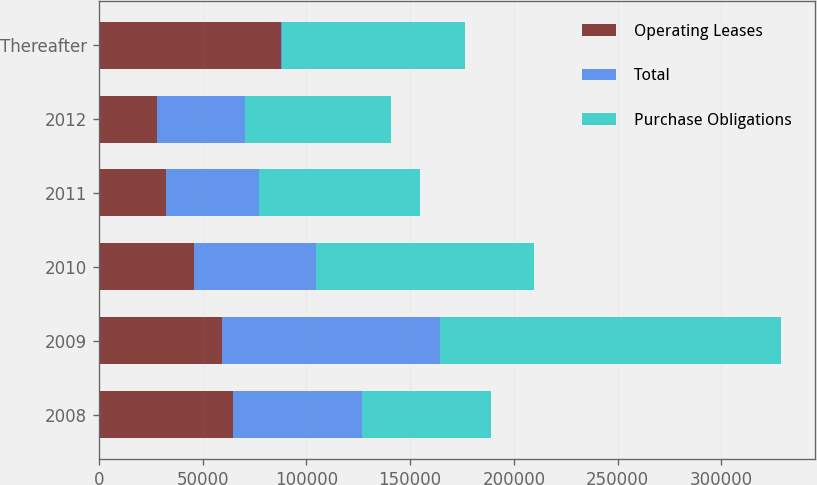Convert chart to OTSL. <chart><loc_0><loc_0><loc_500><loc_500><stacked_bar_chart><ecel><fcel>2008<fcel>2009<fcel>2010<fcel>2011<fcel>2012<fcel>Thereafter<nl><fcel>Operating Leases<fcel>64870<fcel>59221<fcel>45960<fcel>32342<fcel>27940<fcel>87688<nl><fcel>Total<fcel>62045.5<fcel>105099<fcel>58786<fcel>45019<fcel>42563<fcel>643<nl><fcel>Purchase Obligations<fcel>62045.5<fcel>164320<fcel>104746<fcel>77361<fcel>70503<fcel>88331<nl></chart> 